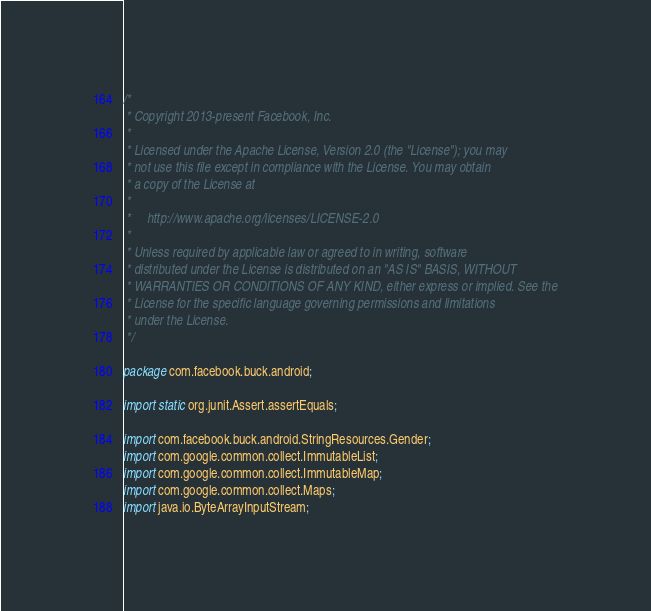<code> <loc_0><loc_0><loc_500><loc_500><_Java_>/*
 * Copyright 2013-present Facebook, Inc.
 *
 * Licensed under the Apache License, Version 2.0 (the "License"); you may
 * not use this file except in compliance with the License. You may obtain
 * a copy of the License at
 *
 *     http://www.apache.org/licenses/LICENSE-2.0
 *
 * Unless required by applicable law or agreed to in writing, software
 * distributed under the License is distributed on an "AS IS" BASIS, WITHOUT
 * WARRANTIES OR CONDITIONS OF ANY KIND, either express or implied. See the
 * License for the specific language governing permissions and limitations
 * under the License.
 */

package com.facebook.buck.android;

import static org.junit.Assert.assertEquals;

import com.facebook.buck.android.StringResources.Gender;
import com.google.common.collect.ImmutableList;
import com.google.common.collect.ImmutableMap;
import com.google.common.collect.Maps;
import java.io.ByteArrayInputStream;</code> 